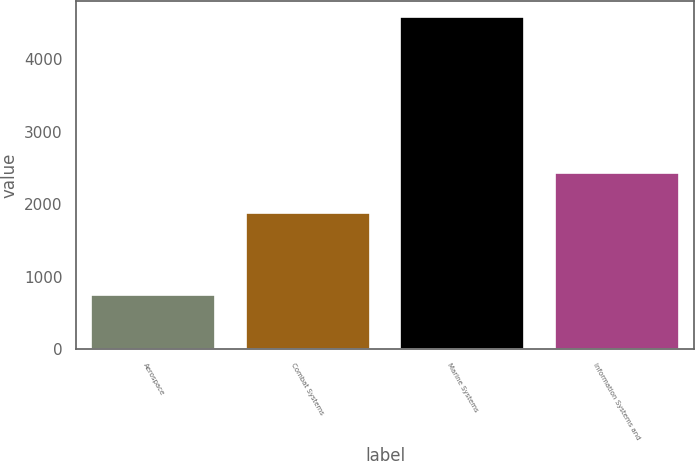Convert chart. <chart><loc_0><loc_0><loc_500><loc_500><bar_chart><fcel>Aerospace<fcel>Combat Systems<fcel>Marine Systems<fcel>Information Systems and<nl><fcel>752<fcel>1883<fcel>4576<fcel>2432<nl></chart> 